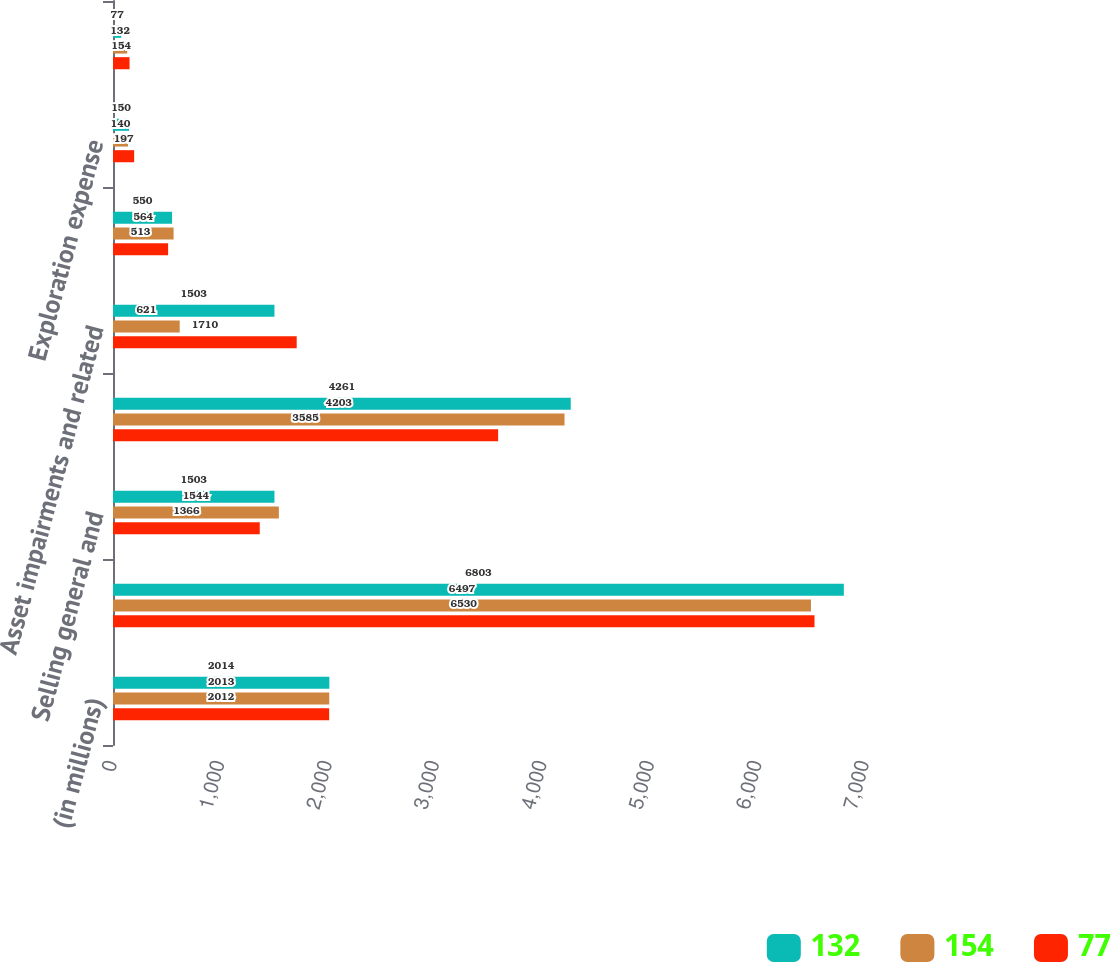Convert chart. <chart><loc_0><loc_0><loc_500><loc_500><stacked_bar_chart><ecel><fcel>(in millions)<fcel>Cost of sales<fcel>Selling general and<fcel>Depreciation depletion and<fcel>Asset impairments and related<fcel>Taxes other than on income<fcel>Exploration expense<fcel>Interest and debt expense net<nl><fcel>132<fcel>2014<fcel>6803<fcel>1503<fcel>4261<fcel>1503<fcel>550<fcel>150<fcel>77<nl><fcel>154<fcel>2013<fcel>6497<fcel>1544<fcel>4203<fcel>621<fcel>564<fcel>140<fcel>132<nl><fcel>77<fcel>2012<fcel>6530<fcel>1366<fcel>3585<fcel>1710<fcel>513<fcel>197<fcel>154<nl></chart> 